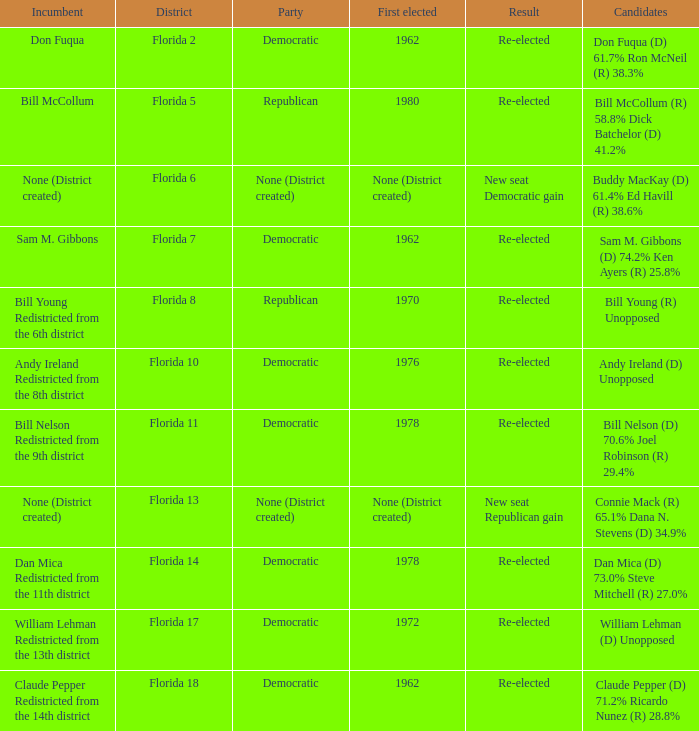Who is the the candidates with incumbent being don fuqua Don Fuqua (D) 61.7% Ron McNeil (R) 38.3%. 